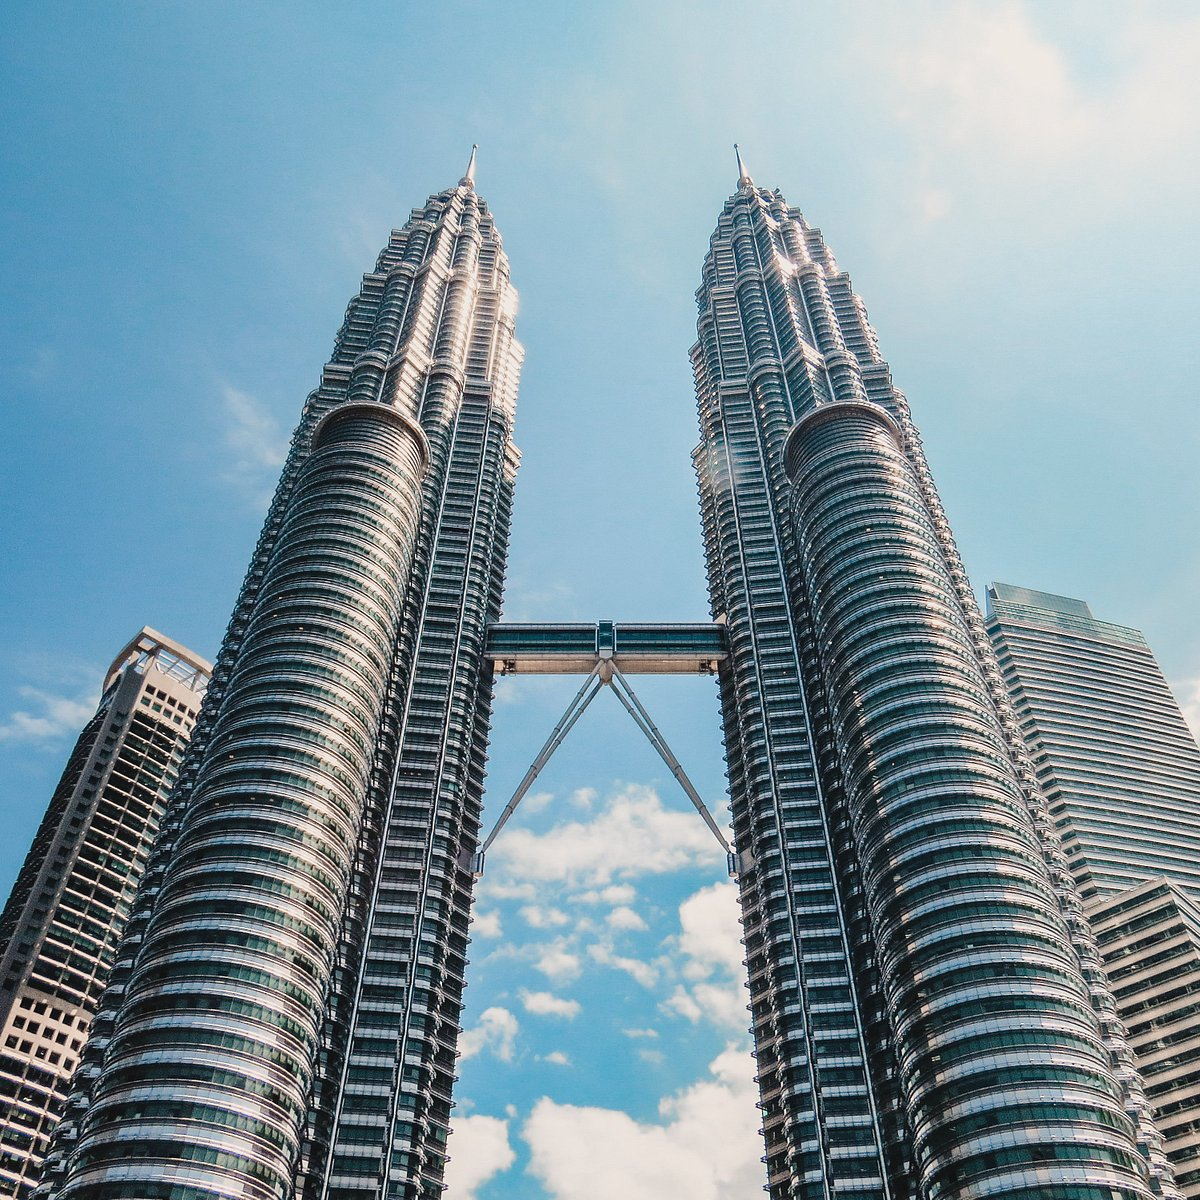Write a detailed description of the given image. The image showcases the illustrious Petronas Twin Towers located in the heart of Kuala Lumpur, Malaysia. Standing as one of the tallest and most distinctive skyscrapers in the world, these towers are engineered from a combination of steel, glass, and reinforced concrete, reflecting the cutting-edge of modern architecture and engineering. The towers are connected by a skybridge, which not only serves as a structural marvel but also offers a panoramic viewing deck on the 41st and 42nd floors, allowing visitors to walk between the towers and enjoy breathtaking views of the cityscape. The sky behind the towers is bright and clear, dotted with a scant scattering of white clouds, which accentuates the gleaming surfaces of the towers under the sunlight. This image not only captures the architectural beauty of the towers but also evokes the spirit of Kuala Lumpur as a center of commerce and culture. 